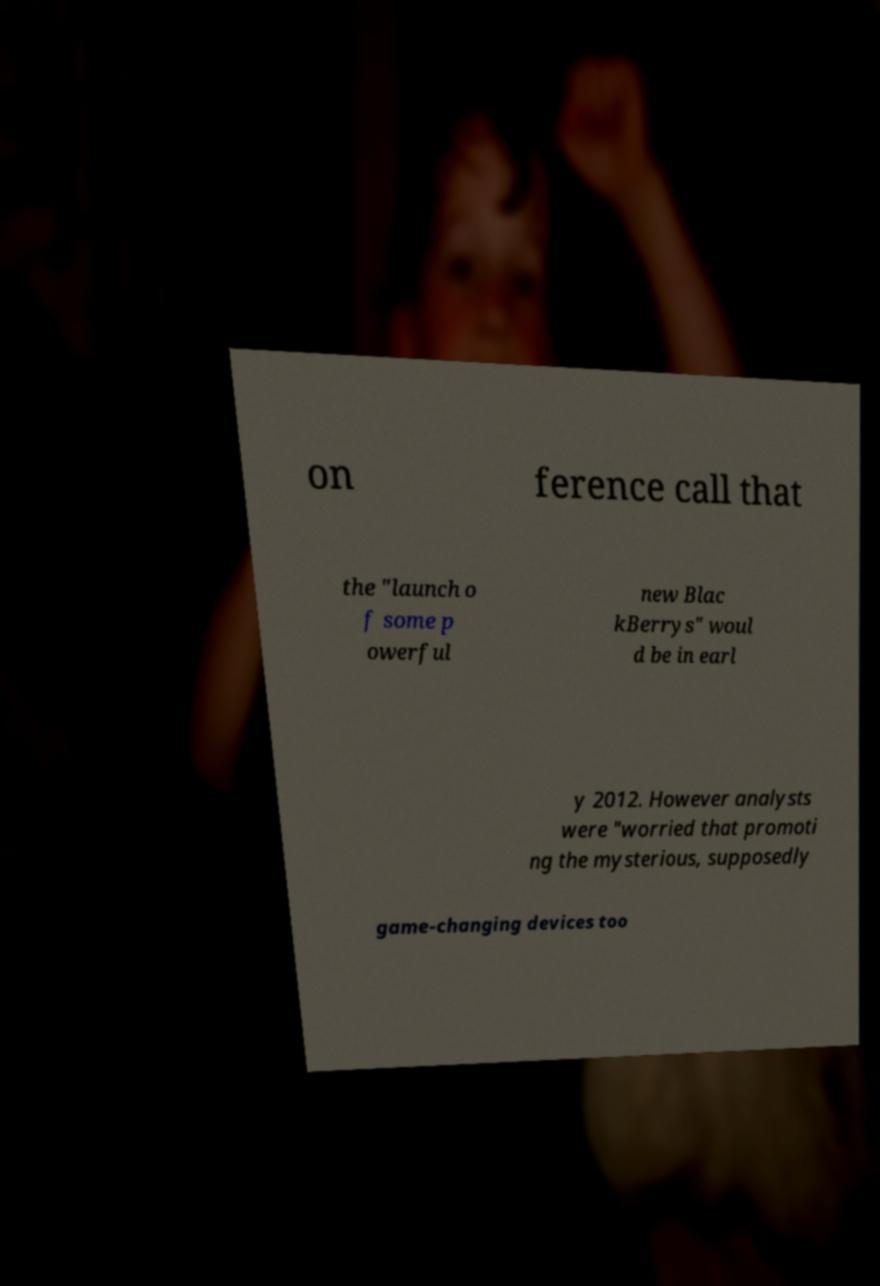What messages or text are displayed in this image? I need them in a readable, typed format. on ference call that the "launch o f some p owerful new Blac kBerrys" woul d be in earl y 2012. However analysts were "worried that promoti ng the mysterious, supposedly game-changing devices too 